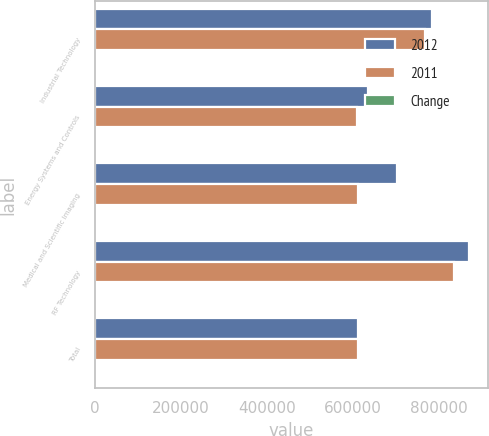<chart> <loc_0><loc_0><loc_500><loc_500><stacked_bar_chart><ecel><fcel>Industrial Technology<fcel>Energy Systems and Controls<fcel>Medical and Scientific Imaging<fcel>RF Technology<fcel>Total<nl><fcel>2012<fcel>783362<fcel>634051<fcel>703034<fcel>871225<fcel>612787<nl><fcel>2011<fcel>767020<fcel>608538<fcel>612787<fcel>834903<fcel>612787<nl><fcel>Change<fcel>2.1<fcel>4.2<fcel>14.7<fcel>4.4<fcel>6<nl></chart> 